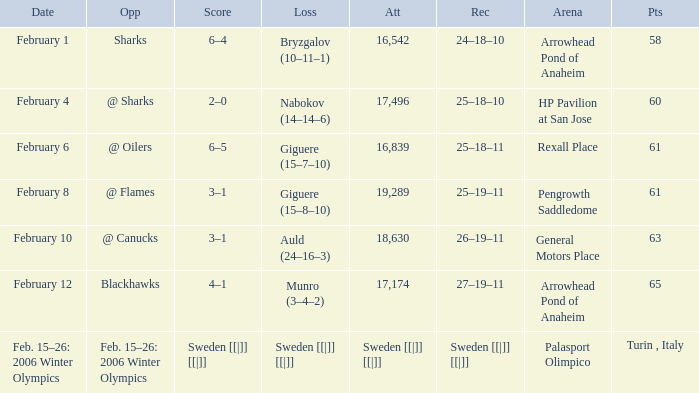What is the record at Palasport Olimpico? Sweden [[|]] [[|]]. 